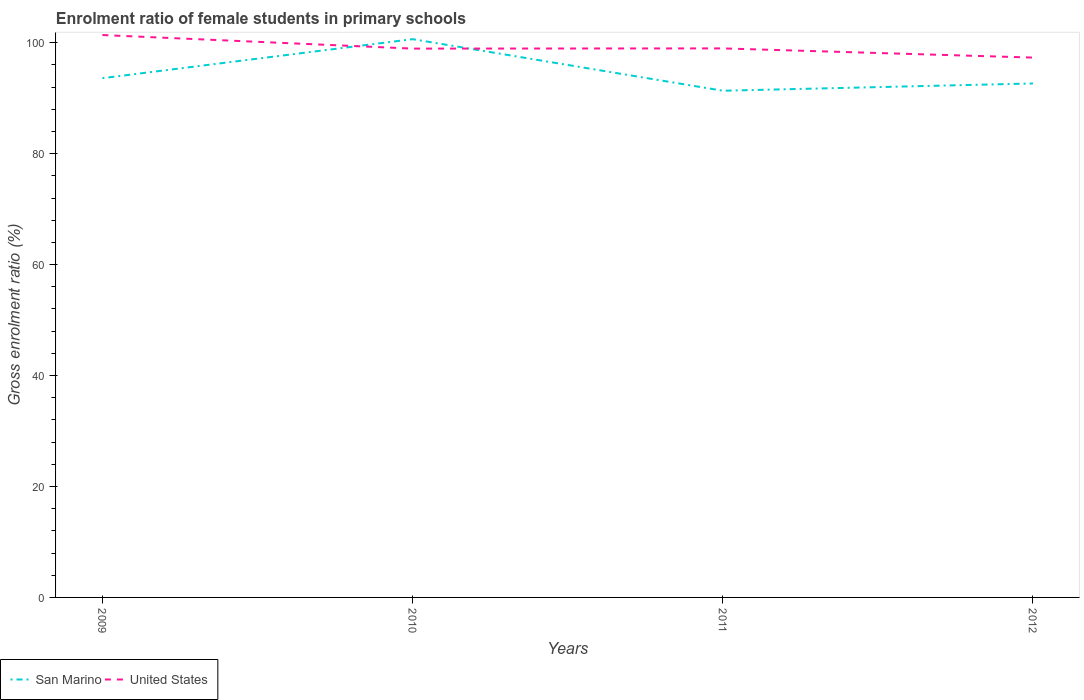Across all years, what is the maximum enrolment ratio of female students in primary schools in United States?
Make the answer very short. 97.31. What is the total enrolment ratio of female students in primary schools in United States in the graph?
Give a very brief answer. 2.45. What is the difference between the highest and the second highest enrolment ratio of female students in primary schools in United States?
Provide a succinct answer. 4.06. What is the difference between the highest and the lowest enrolment ratio of female students in primary schools in San Marino?
Keep it short and to the point. 1. Is the enrolment ratio of female students in primary schools in United States strictly greater than the enrolment ratio of female students in primary schools in San Marino over the years?
Keep it short and to the point. No. How many lines are there?
Offer a very short reply. 2. Are the values on the major ticks of Y-axis written in scientific E-notation?
Make the answer very short. No. Does the graph contain grids?
Your answer should be very brief. No. How many legend labels are there?
Give a very brief answer. 2. What is the title of the graph?
Provide a short and direct response. Enrolment ratio of female students in primary schools. Does "Croatia" appear as one of the legend labels in the graph?
Offer a terse response. No. What is the label or title of the X-axis?
Offer a very short reply. Years. What is the label or title of the Y-axis?
Your answer should be compact. Gross enrolment ratio (%). What is the Gross enrolment ratio (%) in San Marino in 2009?
Make the answer very short. 93.6. What is the Gross enrolment ratio (%) of United States in 2009?
Offer a terse response. 101.38. What is the Gross enrolment ratio (%) in San Marino in 2010?
Offer a very short reply. 100.63. What is the Gross enrolment ratio (%) of United States in 2010?
Keep it short and to the point. 98.93. What is the Gross enrolment ratio (%) of San Marino in 2011?
Keep it short and to the point. 91.34. What is the Gross enrolment ratio (%) of United States in 2011?
Provide a short and direct response. 98.97. What is the Gross enrolment ratio (%) of San Marino in 2012?
Give a very brief answer. 92.65. What is the Gross enrolment ratio (%) in United States in 2012?
Offer a terse response. 97.31. Across all years, what is the maximum Gross enrolment ratio (%) of San Marino?
Keep it short and to the point. 100.63. Across all years, what is the maximum Gross enrolment ratio (%) of United States?
Ensure brevity in your answer.  101.38. Across all years, what is the minimum Gross enrolment ratio (%) in San Marino?
Offer a very short reply. 91.34. Across all years, what is the minimum Gross enrolment ratio (%) in United States?
Provide a succinct answer. 97.31. What is the total Gross enrolment ratio (%) of San Marino in the graph?
Ensure brevity in your answer.  378.22. What is the total Gross enrolment ratio (%) in United States in the graph?
Give a very brief answer. 396.59. What is the difference between the Gross enrolment ratio (%) of San Marino in 2009 and that in 2010?
Provide a short and direct response. -7.03. What is the difference between the Gross enrolment ratio (%) in United States in 2009 and that in 2010?
Make the answer very short. 2.45. What is the difference between the Gross enrolment ratio (%) of San Marino in 2009 and that in 2011?
Provide a short and direct response. 2.26. What is the difference between the Gross enrolment ratio (%) of United States in 2009 and that in 2011?
Offer a very short reply. 2.41. What is the difference between the Gross enrolment ratio (%) in San Marino in 2009 and that in 2012?
Keep it short and to the point. 0.96. What is the difference between the Gross enrolment ratio (%) of United States in 2009 and that in 2012?
Offer a terse response. 4.06. What is the difference between the Gross enrolment ratio (%) of San Marino in 2010 and that in 2011?
Your answer should be compact. 9.3. What is the difference between the Gross enrolment ratio (%) of United States in 2010 and that in 2011?
Keep it short and to the point. -0.04. What is the difference between the Gross enrolment ratio (%) in San Marino in 2010 and that in 2012?
Your answer should be very brief. 7.99. What is the difference between the Gross enrolment ratio (%) of United States in 2010 and that in 2012?
Your answer should be very brief. 1.62. What is the difference between the Gross enrolment ratio (%) in San Marino in 2011 and that in 2012?
Provide a short and direct response. -1.31. What is the difference between the Gross enrolment ratio (%) of United States in 2011 and that in 2012?
Offer a very short reply. 1.66. What is the difference between the Gross enrolment ratio (%) in San Marino in 2009 and the Gross enrolment ratio (%) in United States in 2010?
Provide a short and direct response. -5.33. What is the difference between the Gross enrolment ratio (%) of San Marino in 2009 and the Gross enrolment ratio (%) of United States in 2011?
Give a very brief answer. -5.37. What is the difference between the Gross enrolment ratio (%) of San Marino in 2009 and the Gross enrolment ratio (%) of United States in 2012?
Offer a terse response. -3.71. What is the difference between the Gross enrolment ratio (%) in San Marino in 2010 and the Gross enrolment ratio (%) in United States in 2011?
Your answer should be very brief. 1.67. What is the difference between the Gross enrolment ratio (%) in San Marino in 2010 and the Gross enrolment ratio (%) in United States in 2012?
Your answer should be very brief. 3.32. What is the difference between the Gross enrolment ratio (%) of San Marino in 2011 and the Gross enrolment ratio (%) of United States in 2012?
Your answer should be compact. -5.98. What is the average Gross enrolment ratio (%) of San Marino per year?
Make the answer very short. 94.55. What is the average Gross enrolment ratio (%) of United States per year?
Your answer should be very brief. 99.15. In the year 2009, what is the difference between the Gross enrolment ratio (%) in San Marino and Gross enrolment ratio (%) in United States?
Keep it short and to the point. -7.78. In the year 2010, what is the difference between the Gross enrolment ratio (%) of San Marino and Gross enrolment ratio (%) of United States?
Give a very brief answer. 1.7. In the year 2011, what is the difference between the Gross enrolment ratio (%) of San Marino and Gross enrolment ratio (%) of United States?
Your answer should be very brief. -7.63. In the year 2012, what is the difference between the Gross enrolment ratio (%) in San Marino and Gross enrolment ratio (%) in United States?
Provide a short and direct response. -4.67. What is the ratio of the Gross enrolment ratio (%) in San Marino in 2009 to that in 2010?
Provide a short and direct response. 0.93. What is the ratio of the Gross enrolment ratio (%) in United States in 2009 to that in 2010?
Keep it short and to the point. 1.02. What is the ratio of the Gross enrolment ratio (%) in San Marino in 2009 to that in 2011?
Your answer should be very brief. 1.02. What is the ratio of the Gross enrolment ratio (%) in United States in 2009 to that in 2011?
Offer a very short reply. 1.02. What is the ratio of the Gross enrolment ratio (%) of San Marino in 2009 to that in 2012?
Your response must be concise. 1.01. What is the ratio of the Gross enrolment ratio (%) of United States in 2009 to that in 2012?
Offer a terse response. 1.04. What is the ratio of the Gross enrolment ratio (%) in San Marino in 2010 to that in 2011?
Provide a succinct answer. 1.1. What is the ratio of the Gross enrolment ratio (%) of San Marino in 2010 to that in 2012?
Provide a succinct answer. 1.09. What is the ratio of the Gross enrolment ratio (%) in United States in 2010 to that in 2012?
Provide a succinct answer. 1.02. What is the ratio of the Gross enrolment ratio (%) of San Marino in 2011 to that in 2012?
Your answer should be compact. 0.99. What is the ratio of the Gross enrolment ratio (%) in United States in 2011 to that in 2012?
Your answer should be compact. 1.02. What is the difference between the highest and the second highest Gross enrolment ratio (%) in San Marino?
Give a very brief answer. 7.03. What is the difference between the highest and the second highest Gross enrolment ratio (%) of United States?
Offer a very short reply. 2.41. What is the difference between the highest and the lowest Gross enrolment ratio (%) of San Marino?
Make the answer very short. 9.3. What is the difference between the highest and the lowest Gross enrolment ratio (%) of United States?
Provide a short and direct response. 4.06. 